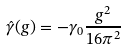Convert formula to latex. <formula><loc_0><loc_0><loc_500><loc_500>\hat { \gamma } ( g ) = - \gamma _ { 0 } \frac { g ^ { 2 } } { 1 6 \pi ^ { 2 } }</formula> 